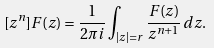<formula> <loc_0><loc_0><loc_500><loc_500>[ z ^ { n } ] F ( z ) = \frac { 1 } { 2 \pi i } \int _ { | z | = r } \frac { F ( z ) } { z ^ { n + 1 } } \, d z .</formula> 